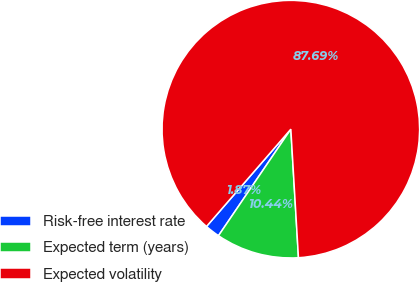Convert chart. <chart><loc_0><loc_0><loc_500><loc_500><pie_chart><fcel>Risk-free interest rate<fcel>Expected term (years)<fcel>Expected volatility<nl><fcel>1.87%<fcel>10.44%<fcel>87.69%<nl></chart> 